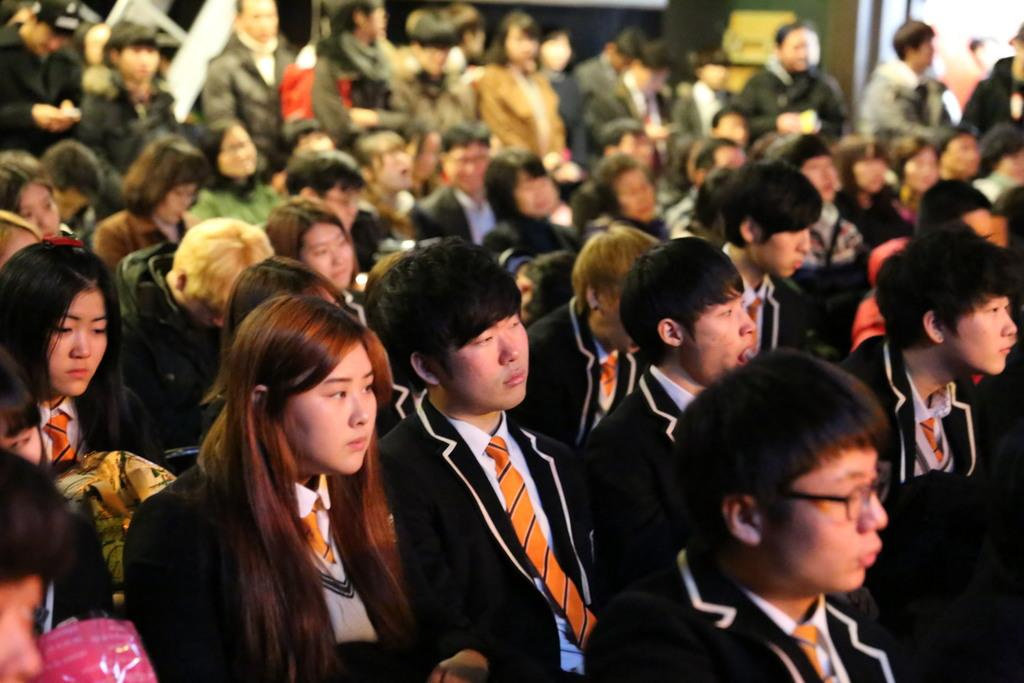What is happening in the foreground of the image? There is a group of people in the foreground of the image. What are some of the people in the group doing? Some of the people are sitting, while others are standing. What type of insect can be seen crawling on the police officer's lock in the image? There is no insect or police officer present in the image, and therefore no such interaction can be observed. 